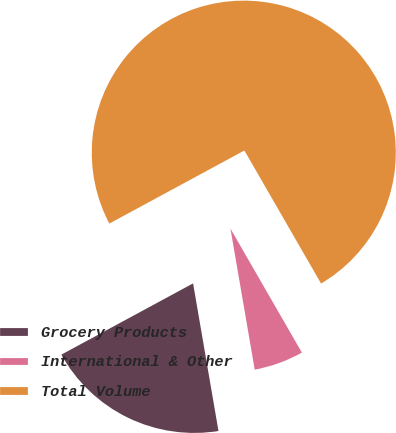Convert chart. <chart><loc_0><loc_0><loc_500><loc_500><pie_chart><fcel>Grocery Products<fcel>International & Other<fcel>Total Volume<nl><fcel>19.82%<fcel>5.61%<fcel>74.57%<nl></chart> 